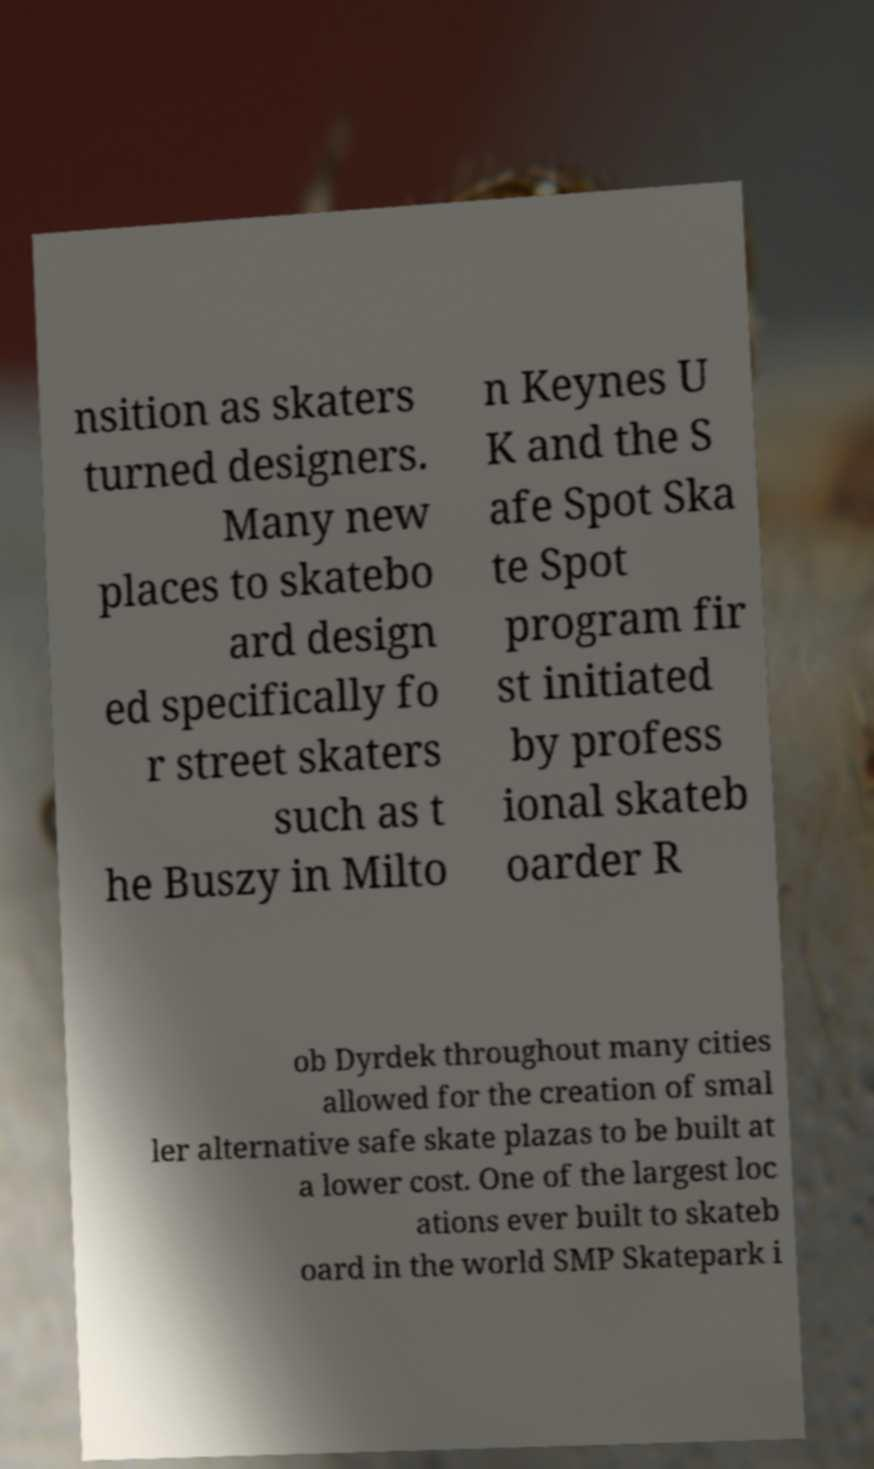Could you assist in decoding the text presented in this image and type it out clearly? nsition as skaters turned designers. Many new places to skatebo ard design ed specifically fo r street skaters such as t he Buszy in Milto n Keynes U K and the S afe Spot Ska te Spot program fir st initiated by profess ional skateb oarder R ob Dyrdek throughout many cities allowed for the creation of smal ler alternative safe skate plazas to be built at a lower cost. One of the largest loc ations ever built to skateb oard in the world SMP Skatepark i 